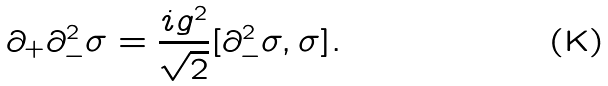Convert formula to latex. <formula><loc_0><loc_0><loc_500><loc_500>\partial _ { + } \partial _ { - } ^ { 2 } \sigma = \frac { i g ^ { 2 } } { \sqrt { 2 } } [ \partial _ { - } ^ { 2 } \sigma , \sigma ] .</formula> 